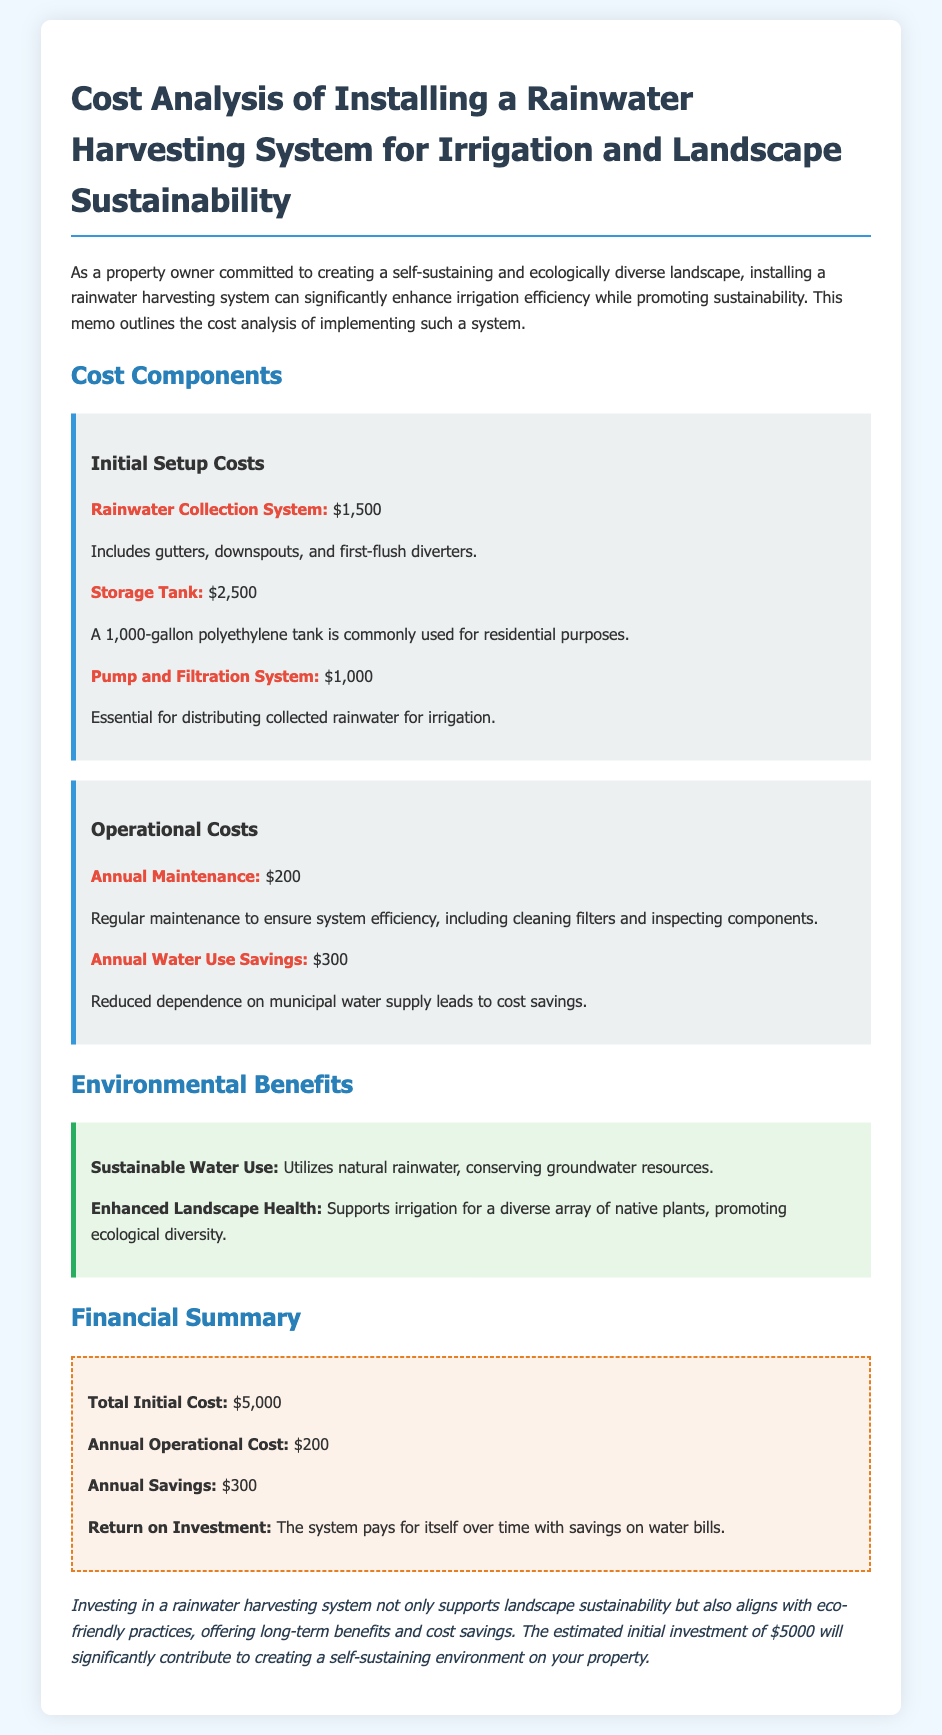what is the total initial cost? The total initial cost is found in the Financial Summary section, which states $5,000.
Answer: $5,000 how much does annual maintenance cost? The annual maintenance cost is detailed under Operational Costs, which is $200.
Answer: $200 what is the estimated annual savings from the system? The estimated annual savings is mentioned in the Financial Summary as $300.
Answer: $300 how much does the rainwater collection system cost? The cost of the rainwater collection system is listed under Initial Setup Costs, which is $1,500.
Answer: $1,500 what is one environmental benefit of the rainwater harvesting system? The environmental benefits section lists "Sustainable Water Use" as one of the benefits.
Answer: Sustainable Water Use how long does it take for the system to pay for itself? The memo implies that the system pays for itself over time with savings on water bills, but it does not specify a time frame.
Answer: over time what type of tank is recommended for storing rainwater? The document specifies that a "1,000-gallon polyethylene tank" is commonly used for residential purposes.
Answer: 1,000-gallon polyethylene tank what are the components included in the rainwater collection system? The rainwater collection system includes gutters, downspouts, and first-flush diverters.
Answer: gutters, downspouts, and first-flush diverters what is the purpose of the pump and filtration system? The purpose is described in the memo as essential for distributing collected rainwater for irrigation.
Answer: distributing collected rainwater for irrigation 